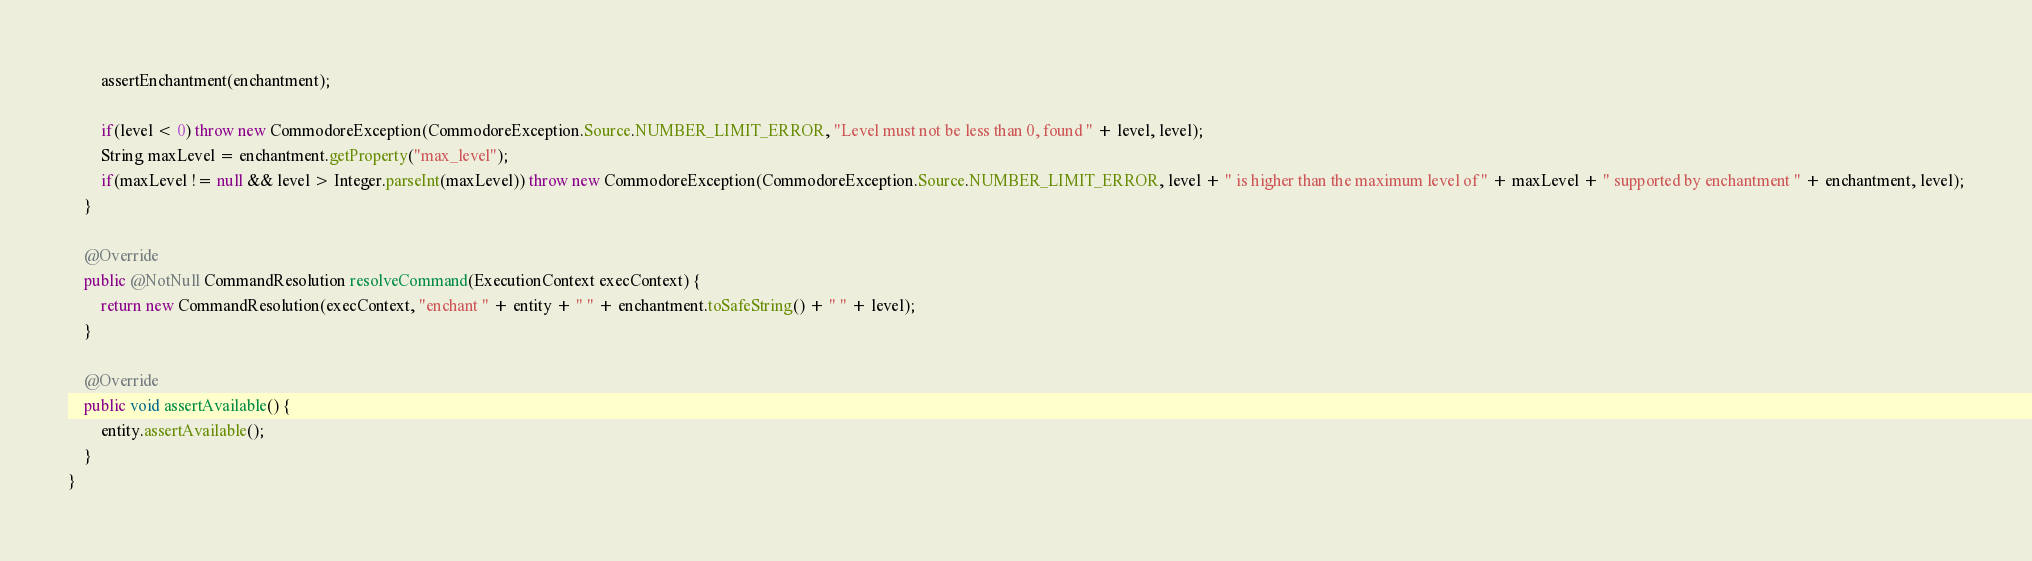Convert code to text. <code><loc_0><loc_0><loc_500><loc_500><_Java_>        assertEnchantment(enchantment);

        if(level < 0) throw new CommodoreException(CommodoreException.Source.NUMBER_LIMIT_ERROR, "Level must not be less than 0, found " + level, level);
        String maxLevel = enchantment.getProperty("max_level");
        if(maxLevel != null && level > Integer.parseInt(maxLevel)) throw new CommodoreException(CommodoreException.Source.NUMBER_LIMIT_ERROR, level + " is higher than the maximum level of " + maxLevel + " supported by enchantment " + enchantment, level);
    }

    @Override
    public @NotNull CommandResolution resolveCommand(ExecutionContext execContext) {
        return new CommandResolution(execContext, "enchant " + entity + " " + enchantment.toSafeString() + " " + level);
    }

    @Override
    public void assertAvailable() {
        entity.assertAvailable();
    }
}
</code> 